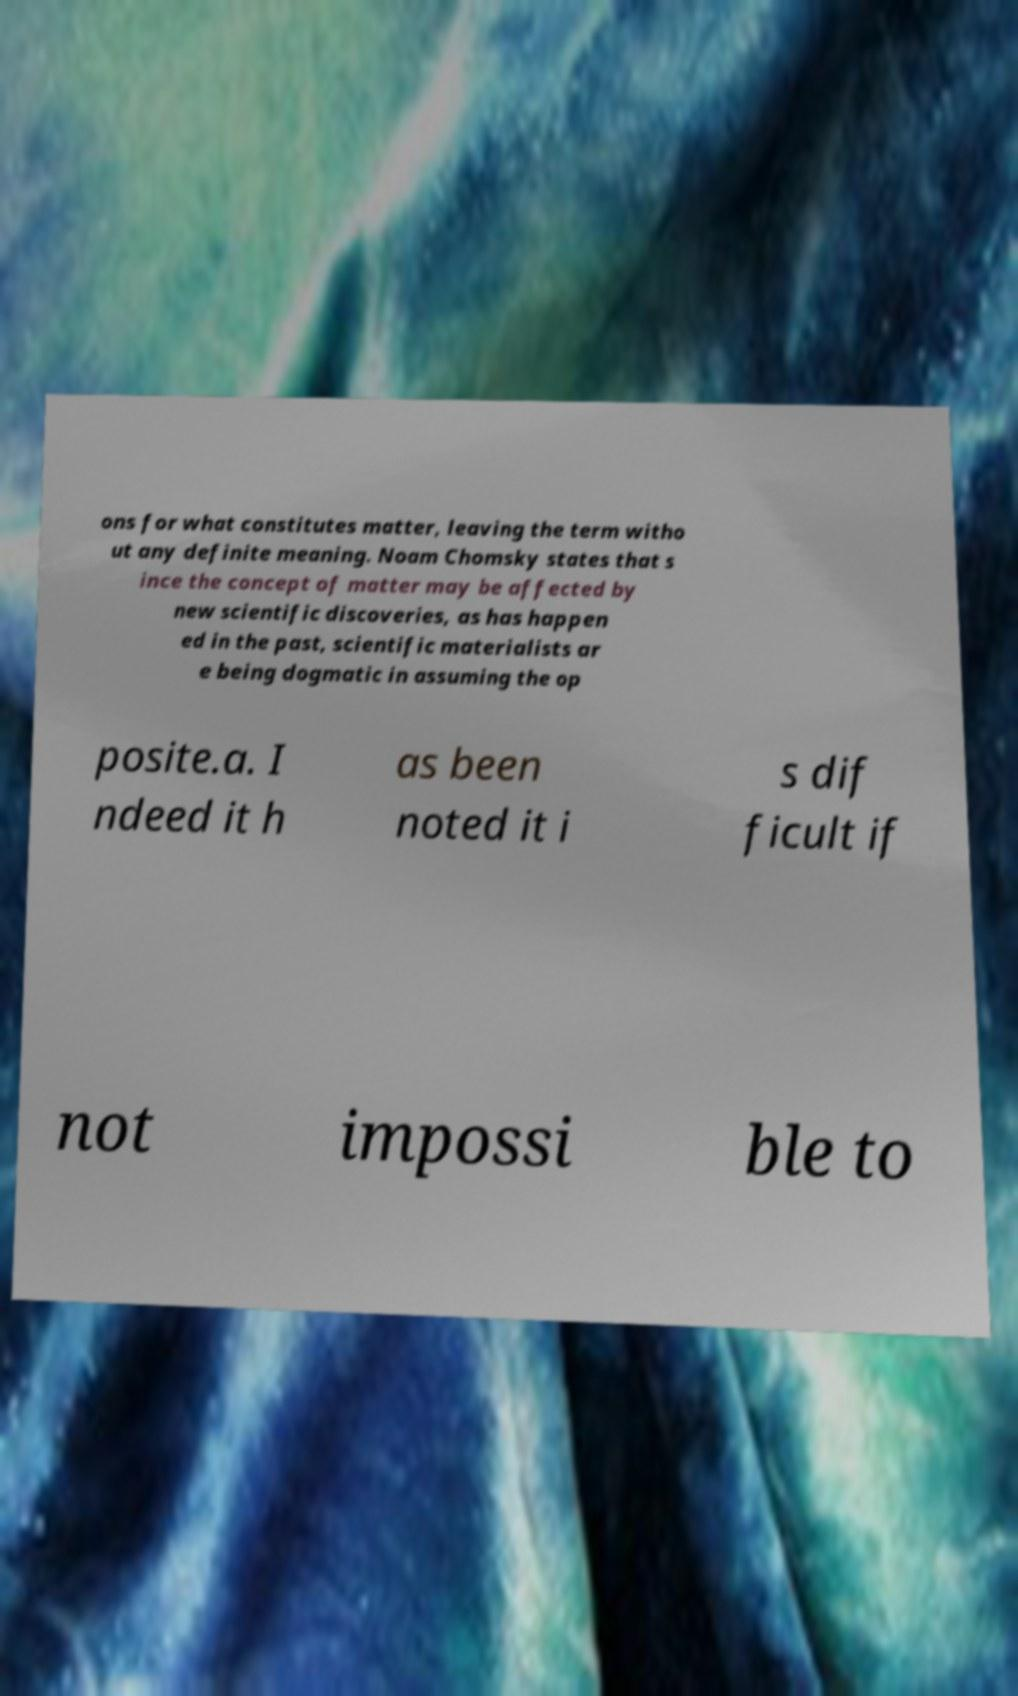Could you assist in decoding the text presented in this image and type it out clearly? ons for what constitutes matter, leaving the term witho ut any definite meaning. Noam Chomsky states that s ince the concept of matter may be affected by new scientific discoveries, as has happen ed in the past, scientific materialists ar e being dogmatic in assuming the op posite.a. I ndeed it h as been noted it i s dif ficult if not impossi ble to 